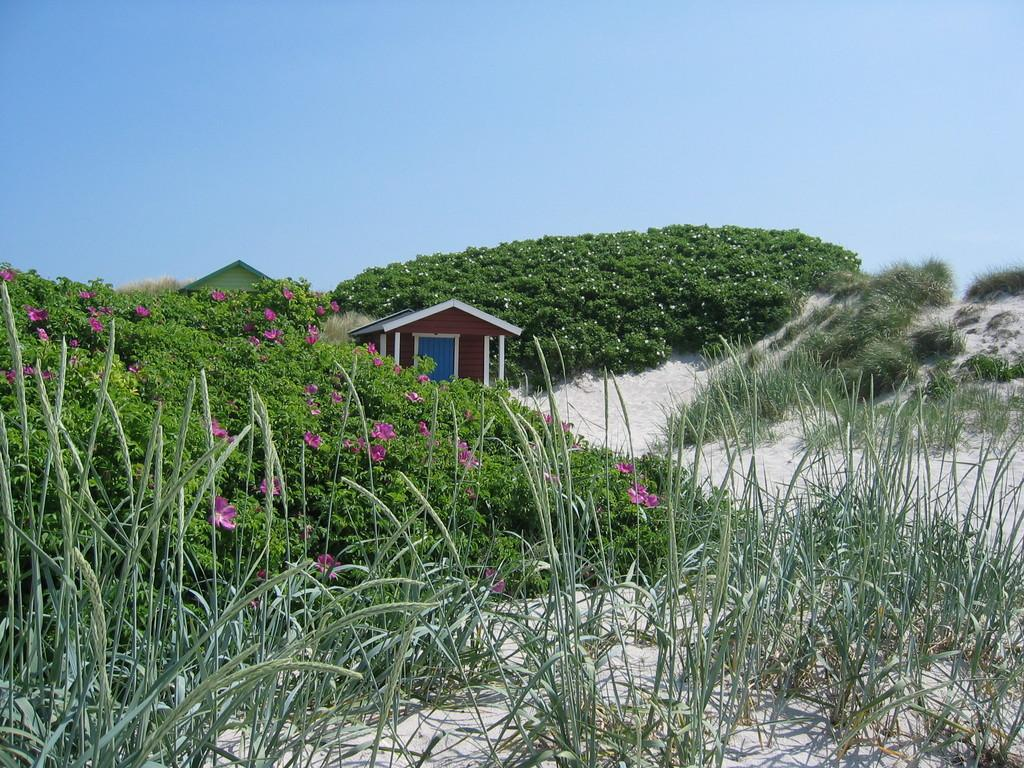What type of living organisms can be seen in the image? Plants and flowers are visible in the image. What type of structures are present in the image? There are houses and a wall in the image. What other objects can be seen in the image? There are poles in the image. What is visible at the top of the image? The sky is visible at the top of the image. What type of plastic material can be seen in the image? There is no plastic material present in the image. What type of beef dish is being prepared in the image? There is no beef dish or any food preparation visible in the image. 